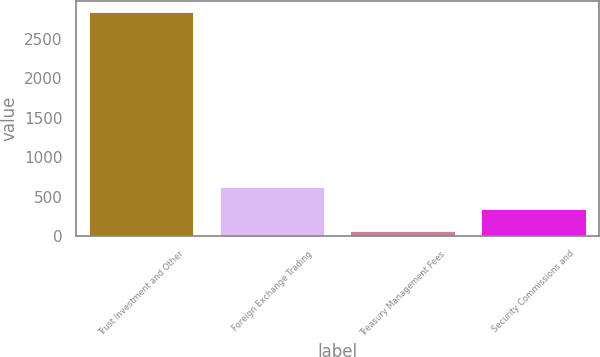<chart> <loc_0><loc_0><loc_500><loc_500><bar_chart><fcel>Trust Investment and Other<fcel>Foreign Exchange Trading<fcel>Treasury Management Fees<fcel>Security Commissions and<nl><fcel>2832.8<fcel>619.36<fcel>66<fcel>342.68<nl></chart> 